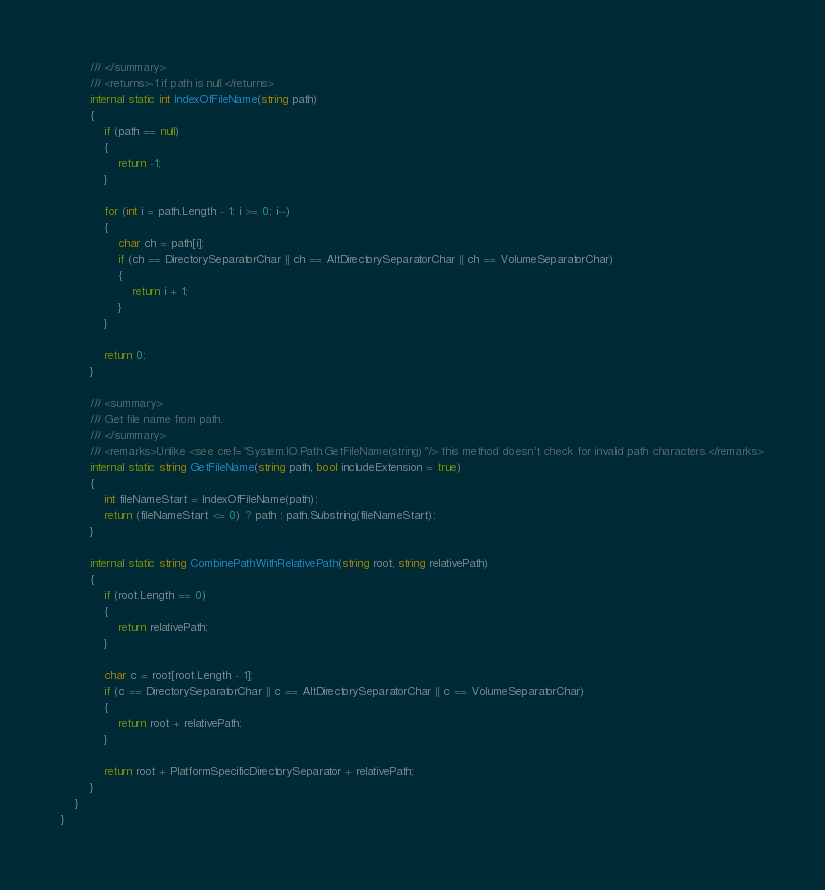<code> <loc_0><loc_0><loc_500><loc_500><_C#_>        /// </summary>
        /// <returns>-1 if path is null.</returns>
        internal static int IndexOfFileName(string path)
        {
            if (path == null)
            {
                return -1;
            }

            for (int i = path.Length - 1; i >= 0; i--)
            {
                char ch = path[i];
                if (ch == DirectorySeparatorChar || ch == AltDirectorySeparatorChar || ch == VolumeSeparatorChar)
                {
                    return i + 1;
                }
            }

            return 0;
        }

        /// <summary>
        /// Get file name from path.
        /// </summary>
        /// <remarks>Unlike <see cref="System.IO.Path.GetFileName(string)"/> this method doesn't check for invalid path characters.</remarks>
        internal static string GetFileName(string path, bool includeExtension = true)
        {
            int fileNameStart = IndexOfFileName(path);
            return (fileNameStart <= 0) ? path : path.Substring(fileNameStart);
        }

        internal static string CombinePathWithRelativePath(string root, string relativePath)
        {
            if (root.Length == 0)
            {
                return relativePath;
            }

            char c = root[root.Length - 1];
            if (c == DirectorySeparatorChar || c == AltDirectorySeparatorChar || c == VolumeSeparatorChar)
            {
                return root + relativePath;
            }

            return root + PlatformSpecificDirectorySeparator + relativePath;
        }
    }
}
</code> 